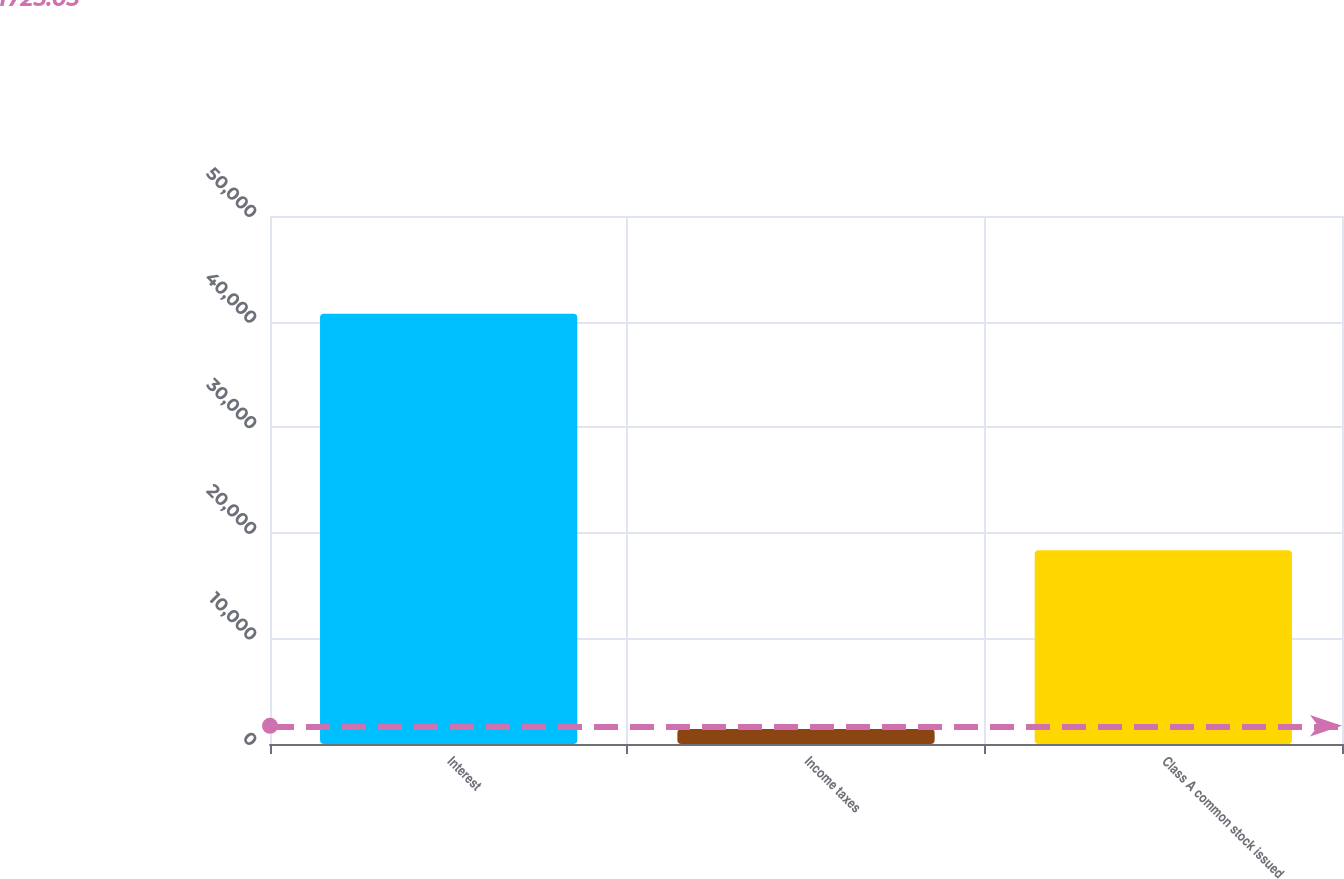<chart> <loc_0><loc_0><loc_500><loc_500><bar_chart><fcel>Interest<fcel>Income taxes<fcel>Class A common stock issued<nl><fcel>40744<fcel>1425<fcel>18346<nl></chart> 